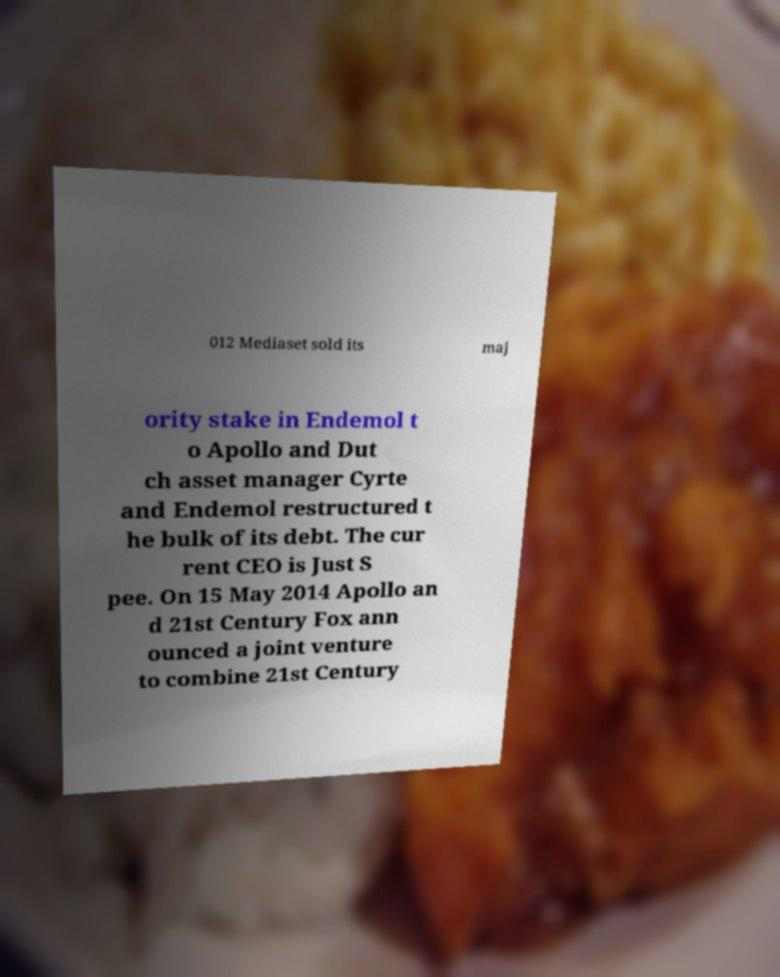What messages or text are displayed in this image? I need them in a readable, typed format. 012 Mediaset sold its maj ority stake in Endemol t o Apollo and Dut ch asset manager Cyrte and Endemol restructured t he bulk of its debt. The cur rent CEO is Just S pee. On 15 May 2014 Apollo an d 21st Century Fox ann ounced a joint venture to combine 21st Century 